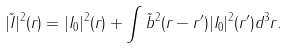<formula> <loc_0><loc_0><loc_500><loc_500>| \tilde { I } | ^ { 2 } ( r ) = | I _ { 0 } | ^ { 2 } ( r ) + \int \tilde { b } ^ { 2 } ( r - r ^ { \prime } ) | I _ { 0 } | ^ { 2 } ( r ^ { \prime } ) d ^ { 3 } r .</formula> 